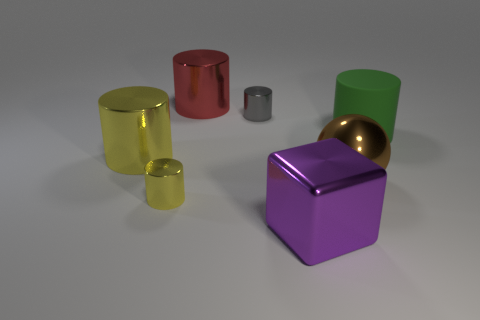Are there any other things that have the same material as the large green object?
Your response must be concise. No. There is a cylinder that is left of the small yellow object; what material is it?
Your answer should be very brief. Metal. There is a yellow object in front of the large brown thing; does it have the same shape as the gray metal thing?
Offer a terse response. Yes. Is there another thing that has the same size as the brown metallic object?
Your response must be concise. Yes. Does the large purple metal thing have the same shape as the large object that is behind the gray thing?
Provide a succinct answer. No. Is the number of purple metallic cubes that are behind the big metal block less than the number of big things?
Ensure brevity in your answer.  Yes. Is the shape of the big red shiny object the same as the brown shiny thing?
Keep it short and to the point. No. There is a gray object that is made of the same material as the sphere; what is its size?
Make the answer very short. Small. Is the number of green metallic things less than the number of small gray metallic things?
Offer a very short reply. Yes. What number of big objects are either green matte cylinders or red metallic cylinders?
Offer a terse response. 2. 